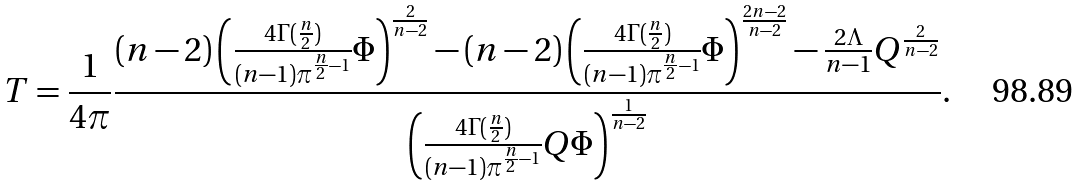<formula> <loc_0><loc_0><loc_500><loc_500>T = \frac { 1 } { 4 \pi } \frac { ( n - 2 ) \left ( \frac { 4 \Gamma ( \frac { n } { 2 } ) } { ( n - 1 ) \pi ^ { \frac { n } { 2 } - 1 } } \Phi \right ) ^ { \frac { 2 } { n - 2 } } - ( n - 2 ) \left ( \frac { 4 \Gamma ( \frac { n } { 2 } ) } { ( n - 1 ) \pi ^ { \frac { n } { 2 } - 1 } } \Phi \right ) ^ { \frac { 2 n - 2 } { n - 2 } } - \frac { 2 \Lambda } { n - 1 } Q ^ { \frac { 2 } { n - 2 } } } { \left ( \frac { 4 \Gamma ( \frac { n } { 2 } ) } { ( n - 1 ) \pi ^ { \frac { n } { 2 } - 1 } } Q \Phi \right ) ^ { \frac { 1 } { n - 2 } } } .</formula> 